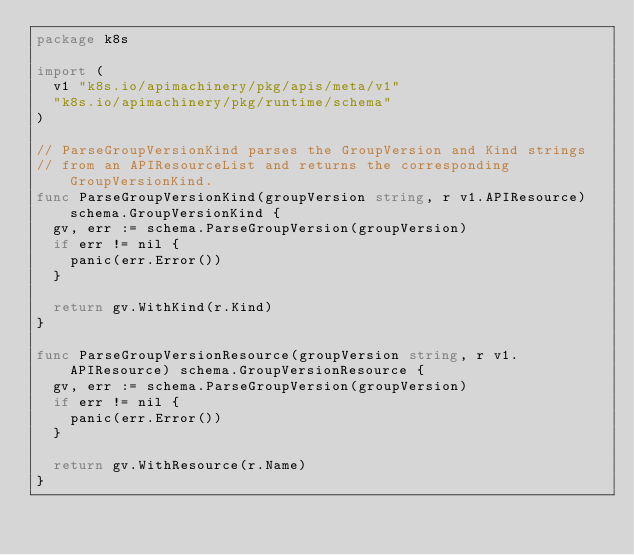<code> <loc_0><loc_0><loc_500><loc_500><_Go_>package k8s

import (
	v1 "k8s.io/apimachinery/pkg/apis/meta/v1"
	"k8s.io/apimachinery/pkg/runtime/schema"
)

// ParseGroupVersionKind parses the GroupVersion and Kind strings
// from an APIResourceList and returns the corresponding GroupVersionKind.
func ParseGroupVersionKind(groupVersion string, r v1.APIResource) schema.GroupVersionKind {
	gv, err := schema.ParseGroupVersion(groupVersion)
	if err != nil {
		panic(err.Error())
	}

	return gv.WithKind(r.Kind)
}

func ParseGroupVersionResource(groupVersion string, r v1.APIResource) schema.GroupVersionResource {
	gv, err := schema.ParseGroupVersion(groupVersion)
	if err != nil {
		panic(err.Error())
	}

	return gv.WithResource(r.Name)
}
</code> 